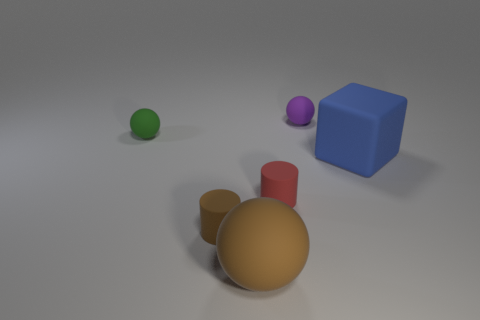Are there any red cylinders made of the same material as the tiny purple object? Upon reviewing the image, it appears that there is indeed a red cylinder present. The tiny purple object in the image seems to be made of a matte material, which is consistent with the finish of the red cylinder. Hence, we can infer that the red cylinder and the tiny purple object are made of the same or at least a visually similar material. 